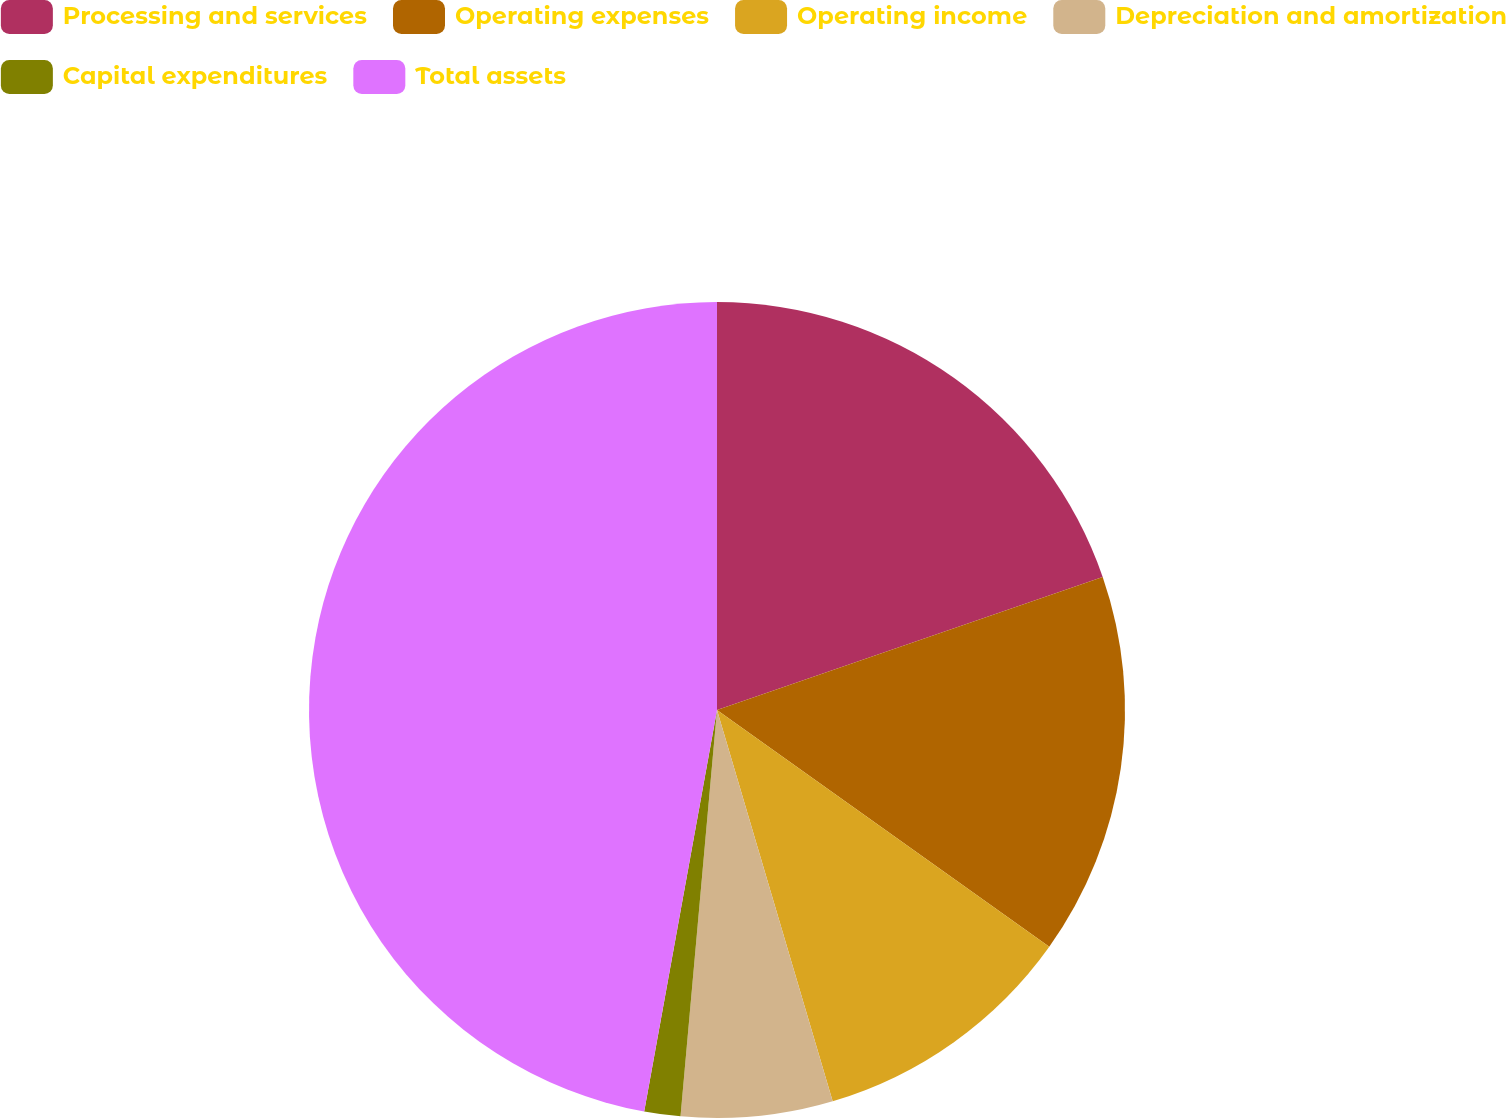<chart> <loc_0><loc_0><loc_500><loc_500><pie_chart><fcel>Processing and services<fcel>Operating expenses<fcel>Operating income<fcel>Depreciation and amortization<fcel>Capital expenditures<fcel>Total assets<nl><fcel>19.71%<fcel>15.14%<fcel>10.57%<fcel>6.0%<fcel>1.43%<fcel>47.14%<nl></chart> 